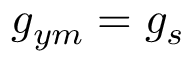<formula> <loc_0><loc_0><loc_500><loc_500>g _ { y m } = g _ { s }</formula> 